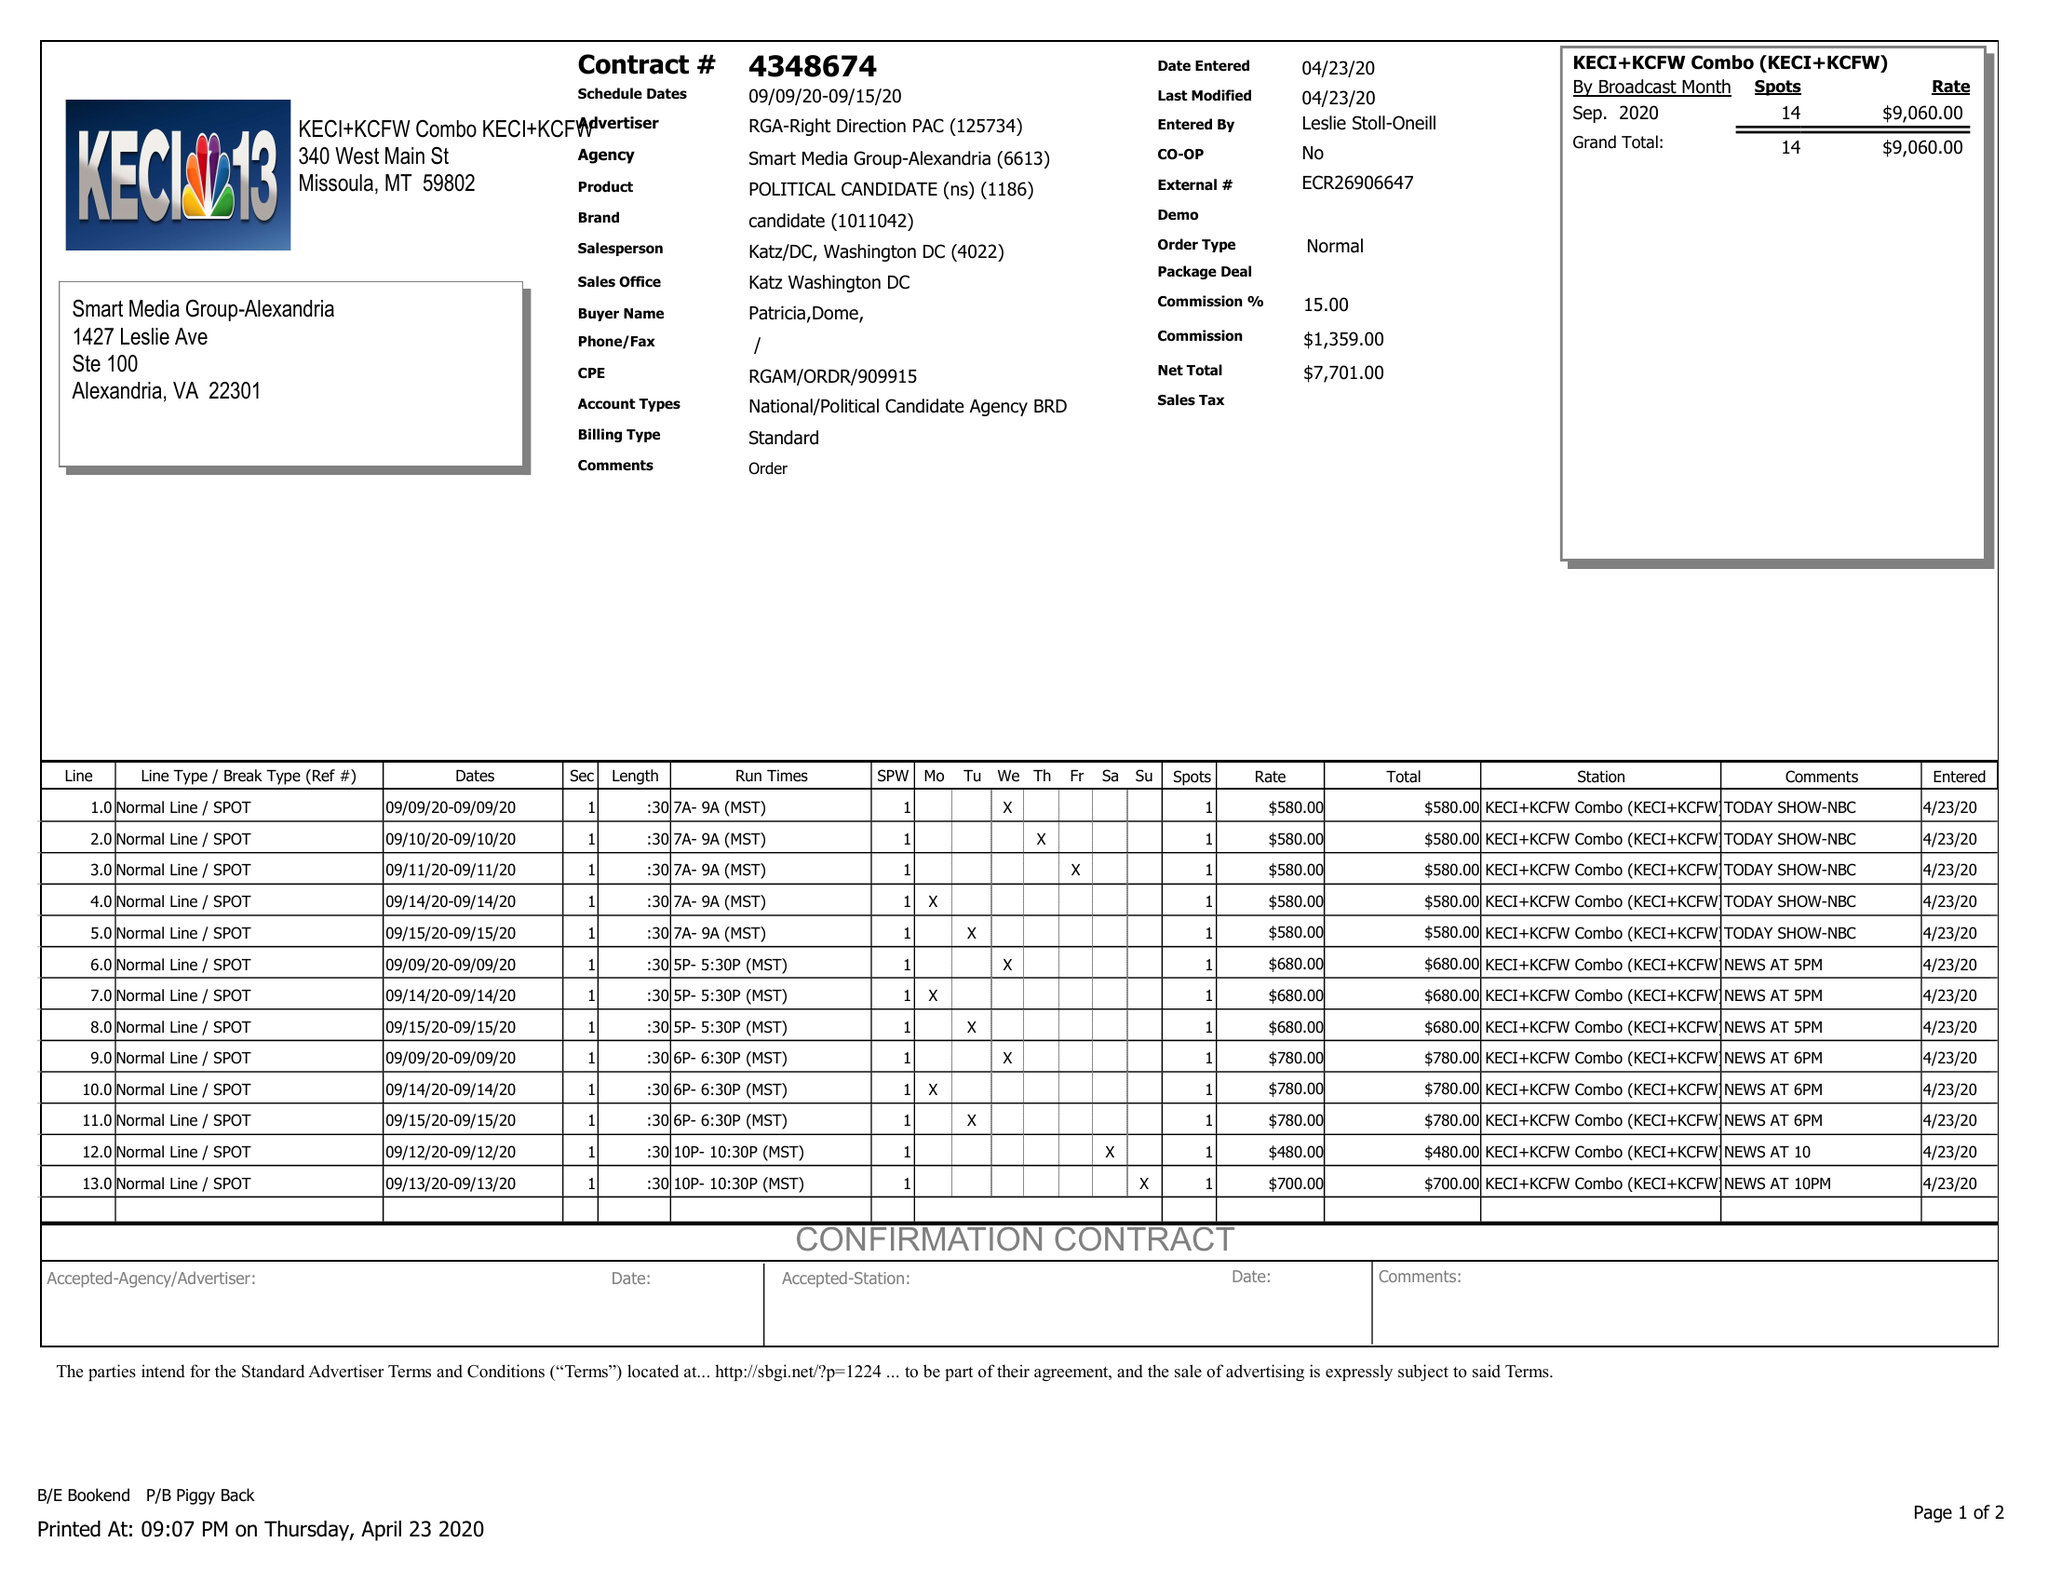What is the value for the advertiser?
Answer the question using a single word or phrase. RGA-RIGHT DIRECTION PAC 